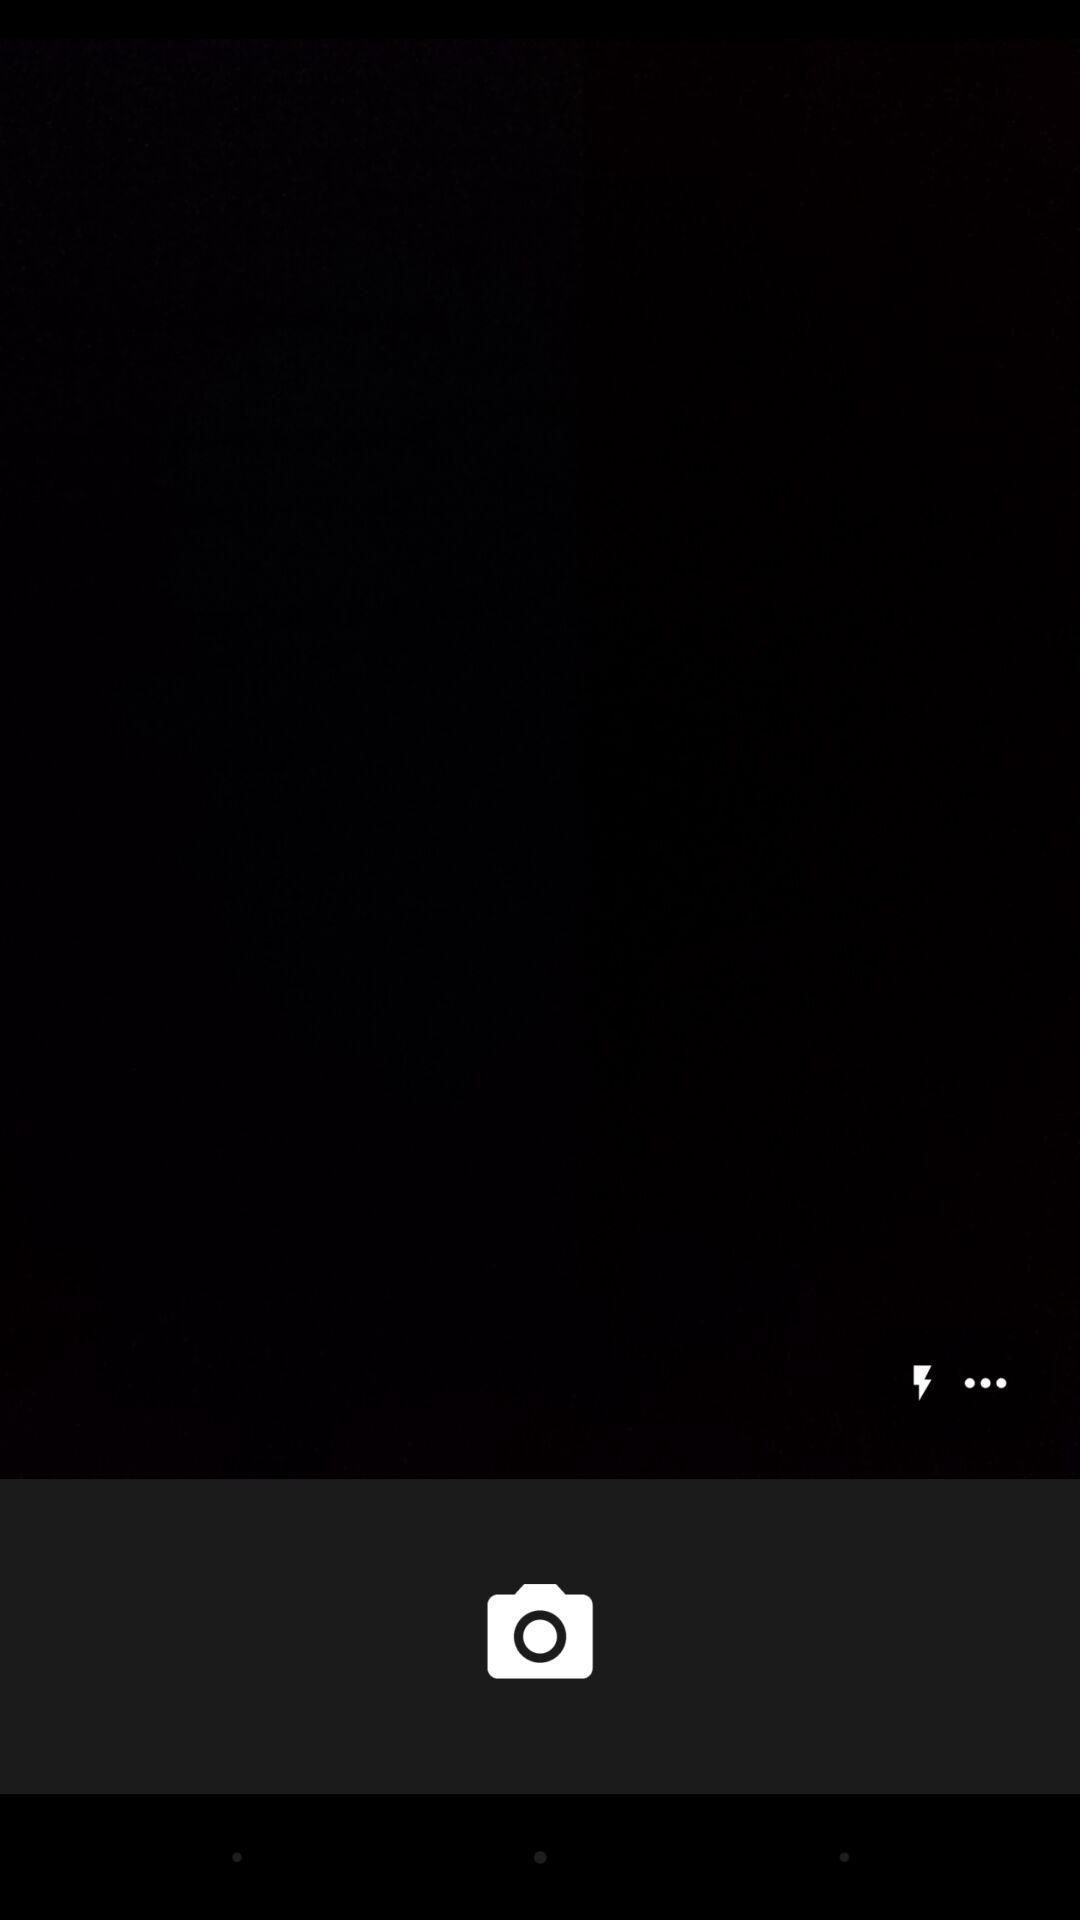How many more dots are there than lightning bolts?
Answer the question using a single word or phrase. 2 